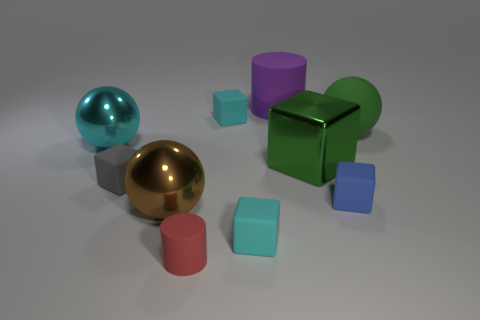Subtract all cyan spheres. How many spheres are left? 2 Subtract all cyan spheres. How many spheres are left? 2 Subtract 2 cylinders. How many cylinders are left? 0 Subtract all brown cylinders. How many cyan blocks are left? 2 Subtract all big green cubes. Subtract all large rubber spheres. How many objects are left? 8 Add 6 tiny cyan cubes. How many tiny cyan cubes are left? 8 Add 8 blue rubber things. How many blue rubber things exist? 9 Subtract 1 blue blocks. How many objects are left? 9 Subtract all cylinders. How many objects are left? 8 Subtract all cyan cubes. Subtract all brown spheres. How many cubes are left? 3 